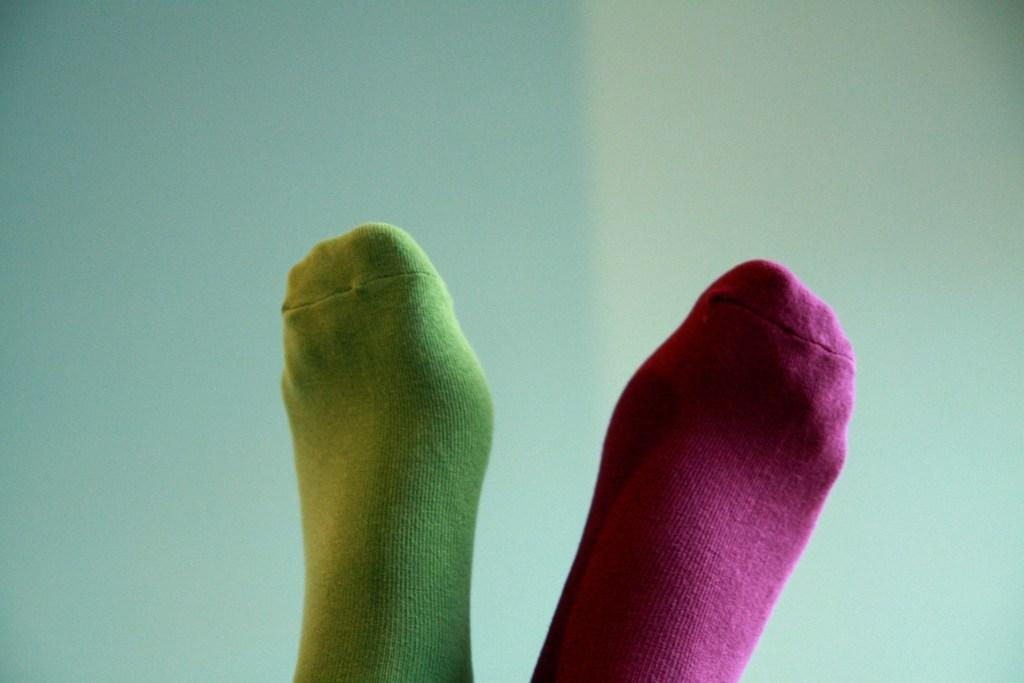What body parts are visible in the image? There are human legs with socks in the image. Can you describe the background of the image? There may be a wall in the background of the image. What type of shoe is the minister wearing in the image? There is no minister or shoe present in the image; it only features human legs with socks. 